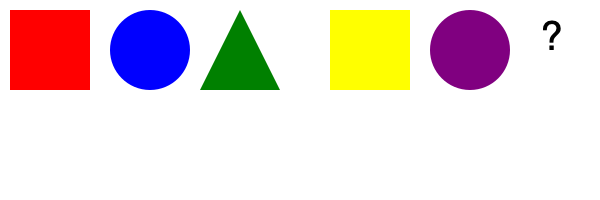As a speedrunner analyzing game level design, what shape and color should logically come next in this sequence of obstacles? To determine the next shape and color in the sequence, we need to analyze the pattern:

1. Shape pattern:
   - Rectangle (red)
   - Circle (blue)
   - Triangle (green)
   - Rectangle (yellow)
   - Circle (purple)
   The pattern repeats: Rectangle, Circle, Triangle

2. Color pattern:
   - Red
   - Blue
   - Green
   - Yellow
   - Purple
   The colors follow the rainbow spectrum (ROYGBIV)

3. Next in sequence:
   - Shape: The next shape should be a Triangle (following Rectangle, Circle)
   - Color: The next color in the spectrum after Purple is Indigo

Therefore, the next obstacle in the sequence should be an Indigo Triangle.
Answer: Indigo Triangle 